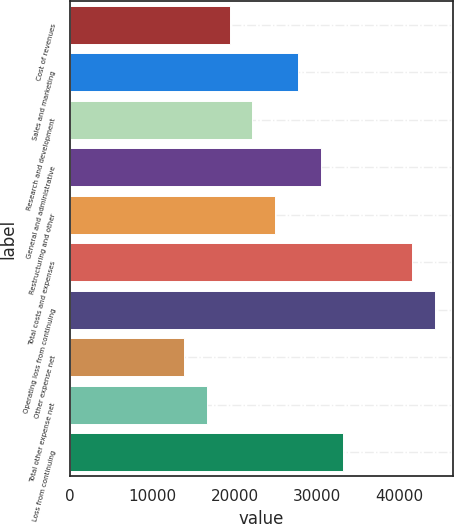Convert chart to OTSL. <chart><loc_0><loc_0><loc_500><loc_500><bar_chart><fcel>Cost of revenues<fcel>Sales and marketing<fcel>Research and development<fcel>General and administrative<fcel>Restructuring and other<fcel>Total costs and expenses<fcel>Operating loss from continuing<fcel>Other expense net<fcel>Total other expense net<fcel>Loss from continuing<nl><fcel>19399.8<fcel>27714<fcel>22171.2<fcel>30485.4<fcel>24942.6<fcel>41571<fcel>44342.4<fcel>13857<fcel>16628.4<fcel>33256.8<nl></chart> 